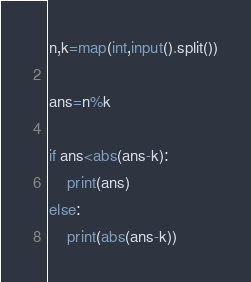<code> <loc_0><loc_0><loc_500><loc_500><_Python_>n,k=map(int,input().split())

ans=n%k

if ans<abs(ans-k):
    print(ans)
else:
    print(abs(ans-k))</code> 